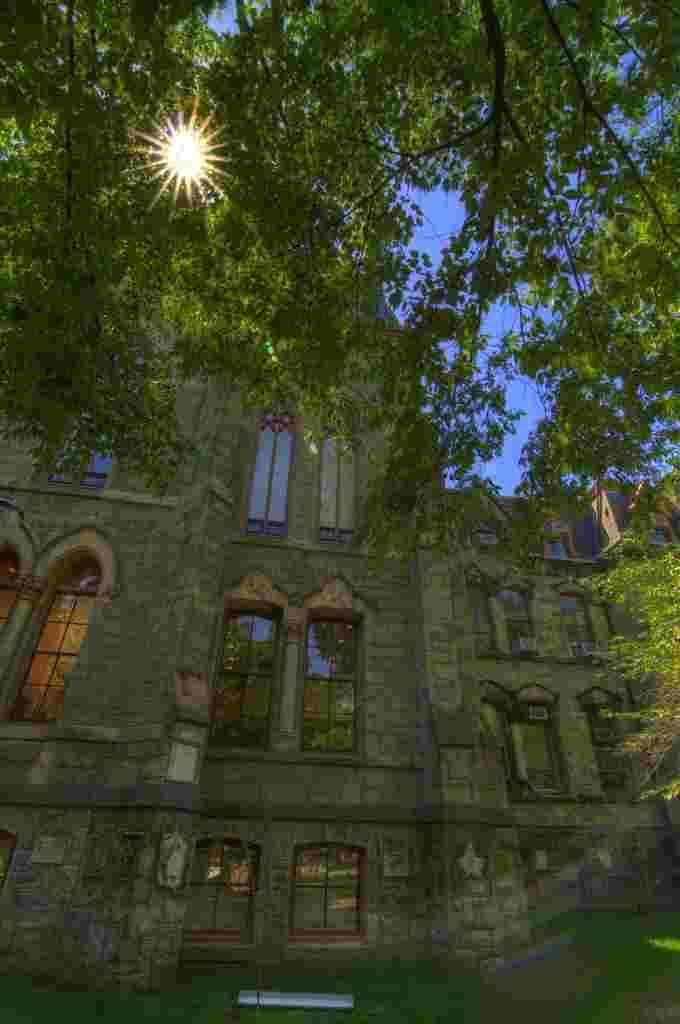Please provide a concise description of this image. This picture might be taken from outside of the city. In this image, we can see a building, glass window. At the top, we can see a sky and a light, at the bottom, we can also see a grass. 